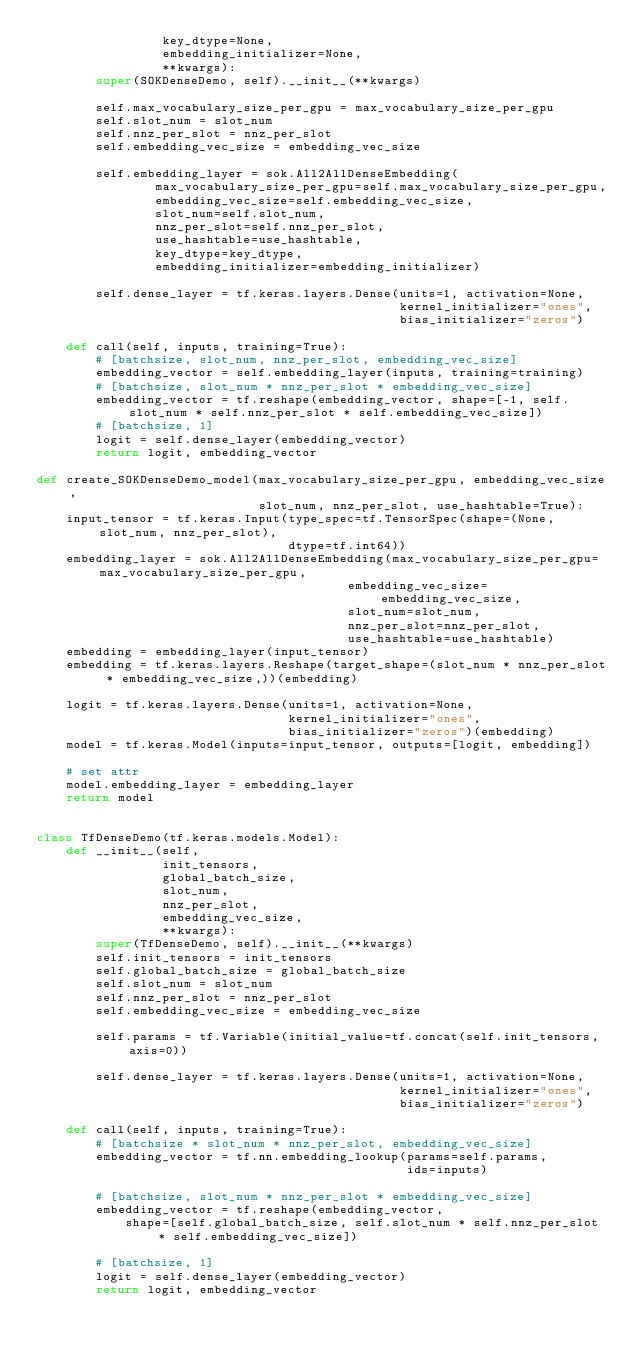Convert code to text. <code><loc_0><loc_0><loc_500><loc_500><_Python_>                 key_dtype=None,
                 embedding_initializer=None,
                 **kwargs):
        super(SOKDenseDemo, self).__init__(**kwargs)

        self.max_vocabulary_size_per_gpu = max_vocabulary_size_per_gpu
        self.slot_num = slot_num
        self.nnz_per_slot = nnz_per_slot
        self.embedding_vec_size = embedding_vec_size

        self.embedding_layer = sok.All2AllDenseEmbedding(
                max_vocabulary_size_per_gpu=self.max_vocabulary_size_per_gpu,
                embedding_vec_size=self.embedding_vec_size,
                slot_num=self.slot_num,
                nnz_per_slot=self.nnz_per_slot,
                use_hashtable=use_hashtable,
                key_dtype=key_dtype,
                embedding_initializer=embedding_initializer)
        
        self.dense_layer = tf.keras.layers.Dense(units=1, activation=None,
                                                 kernel_initializer="ones",
                                                 bias_initializer="zeros")

    def call(self, inputs, training=True):
        # [batchsize, slot_num, nnz_per_slot, embedding_vec_size]
        embedding_vector = self.embedding_layer(inputs, training=training)
        # [batchsize, slot_num * nnz_per_slot * embedding_vec_size]
        embedding_vector = tf.reshape(embedding_vector, shape=[-1, self.slot_num * self.nnz_per_slot * self.embedding_vec_size])
        # [batchsize, 1]
        logit = self.dense_layer(embedding_vector)
        return logit, embedding_vector

def create_SOKDenseDemo_model(max_vocabulary_size_per_gpu, embedding_vec_size,
                              slot_num, nnz_per_slot, use_hashtable=True):
    input_tensor = tf.keras.Input(type_spec=tf.TensorSpec(shape=(None, slot_num, nnz_per_slot), 
                                  dtype=tf.int64))
    embedding_layer = sok.All2AllDenseEmbedding(max_vocabulary_size_per_gpu=max_vocabulary_size_per_gpu,
                                          embedding_vec_size=embedding_vec_size,
                                          slot_num=slot_num,
                                          nnz_per_slot=nnz_per_slot,
                                          use_hashtable=use_hashtable)
    embedding = embedding_layer(input_tensor)
    embedding = tf.keras.layers.Reshape(target_shape=(slot_num * nnz_per_slot * embedding_vec_size,))(embedding)

    logit = tf.keras.layers.Dense(units=1, activation=None,
                                  kernel_initializer="ones",
                                  bias_initializer="zeros")(embedding)
    model = tf.keras.Model(inputs=input_tensor, outputs=[logit, embedding])

    # set attr
    model.embedding_layer = embedding_layer
    return model


class TfDenseDemo(tf.keras.models.Model):
    def __init__(self,
                 init_tensors,
                 global_batch_size,
                 slot_num, 
                 nnz_per_slot,
                 embedding_vec_size,
                 **kwargs):
        super(TfDenseDemo, self).__init__(**kwargs)
        self.init_tensors = init_tensors
        self.global_batch_size = global_batch_size
        self.slot_num = slot_num
        self.nnz_per_slot = nnz_per_slot
        self.embedding_vec_size = embedding_vec_size

        self.params = tf.Variable(initial_value=tf.concat(self.init_tensors, axis=0))

        self.dense_layer = tf.keras.layers.Dense(units=1, activation=None,
                                                 kernel_initializer="ones",
                                                 bias_initializer="zeros")

    def call(self, inputs, training=True):
        # [batchsize * slot_num * nnz_per_slot, embedding_vec_size]
        embedding_vector = tf.nn.embedding_lookup(params=self.params,
                                                  ids=inputs)

        # [batchsize, slot_num * nnz_per_slot * embedding_vec_size]
        embedding_vector = tf.reshape(embedding_vector, 
            shape=[self.global_batch_size, self.slot_num * self.nnz_per_slot * self.embedding_vec_size])
        
        # [batchsize, 1]
        logit = self.dense_layer(embedding_vector)
        return logit, embedding_vector
</code> 